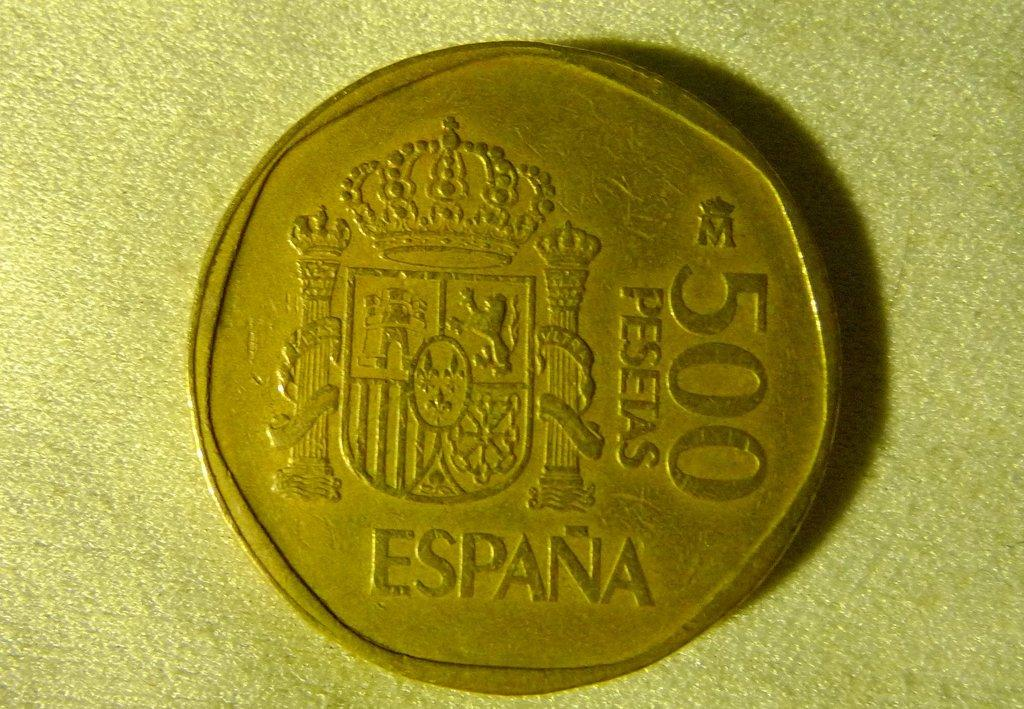<image>
Give a short and clear explanation of the subsequent image. A coin from Spain is worth 500 Pesetas. 